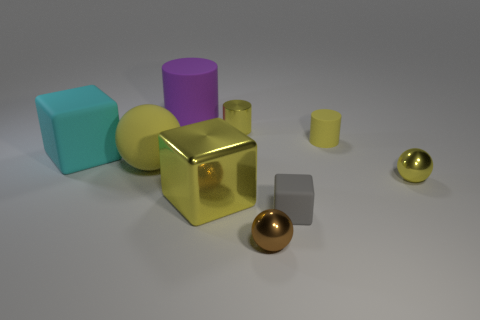How does the lighting in the image affect the appearance of the objects? The lighting in the image seems to be soft and diffused, with few harsh shadows, enhancing the objects' dimensionality and highlighting their reflective qualities, especially of the metallic surfaces. Are the shadows consistent with multiple light sources? From the placement and softness of the shadows, it appears that there may be a single light source or a very well-diffused light setup that produces minimal and soft-edged shadows around the objects. 